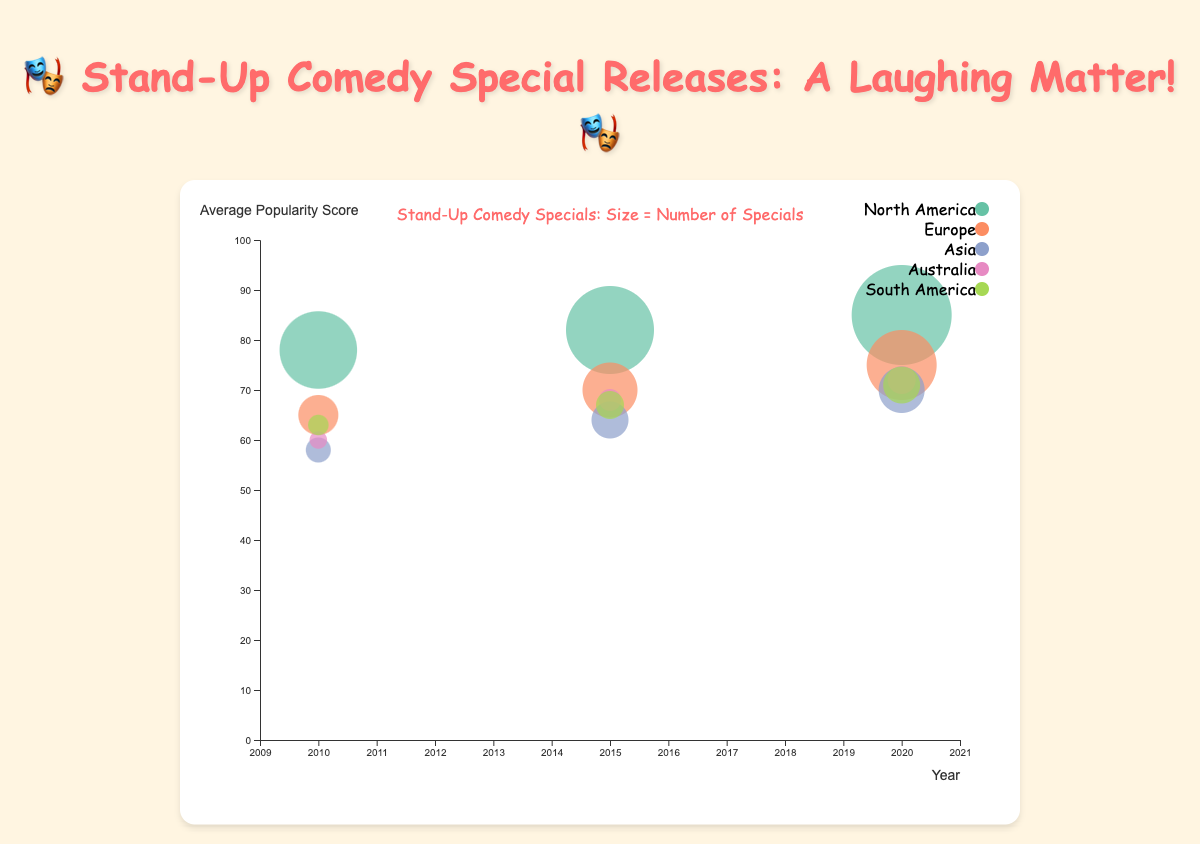What is the title of the chart? The title of the chart is displayed at the top center and reads: "🎭 Stand-Up Comedy Special Releases: A Laughing Matter! 🎭"
Answer: 🎭 Stand-Up Comedy Special Releases: A Laughing Matter! 🎭 How many stand-up comedy specials were released in Europe in 2020? Locate the bubble representing Europe in the year 2020. The size of this bubble corresponds to 40 stand-up comedy specials released.
Answer: 40 Which region had the highest average popularity score in 2020? Find the bubbles for the year 2020 and compare their y-axis positions (average popularity score). The North America bubble is positioned the highest, indicating the highest average popularity score of 85.
Answer: North America What is the trend in the number of stand-up comedy specials released in North America from 2010 to 2020? Observe the difference in bubble sizes across North America for the years 2010, 2015, and 2020. The bubble sizes increase from 45 (2010) to 52 (2015) to 60 (2020), indicating an increasing trend.
Answer: Increasing Compare the average popularity score of stand-up specials between Asia and South America in 2010. Which one is higher? By locating the bubbles for Asia and South America in 2010 and comparing their y-axis positions, the South America bubble is higher than Asia (63 vs. 58). Therefore, South America's is higher.
Answer: South America Which region had a notable increase in the number of specials released between 2010 and 2020? Compare the bubble sizes across different regions for the years 2010 and 2020. Both North America (45 to 60) and Europe (20 to 40) show increases, but North America has the largest absolute increase (+15).
Answer: North America What is the average popularity score of stand-up specials released in Australia in 2015? Find the bubble for Australia in 2015 and refer to the y-axis position, which indicates an average popularity score of 68.
Answer: 68 Are the number of stand-up comedy specials in 2015 and 2020 for Asia similar or different? Compare the bubble sizes for Asia in 2015 and 2020. The sizes are different, with 18 in 2015 and 24 in 2020, an increase.
Answer: Different How many regions are represented in the chart? By looking at the legend which lists each region with a color and marker, we can count a total of five regions: North America, Europe, Asia, Australia, and South America.
Answer: Five 